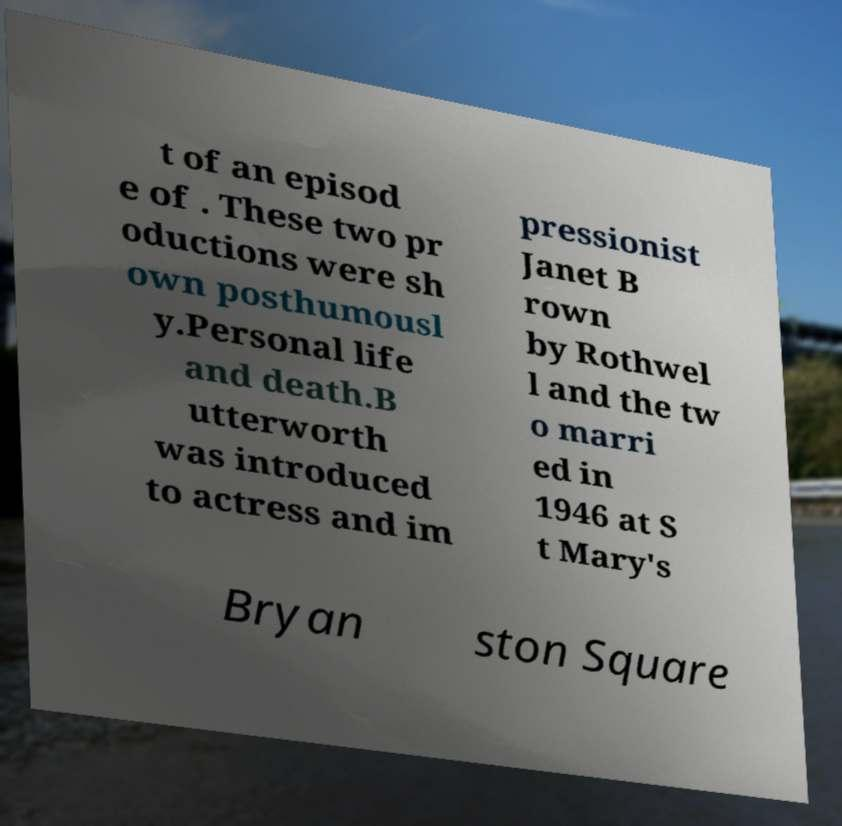Can you read and provide the text displayed in the image?This photo seems to have some interesting text. Can you extract and type it out for me? t of an episod e of . These two pr oductions were sh own posthumousl y.Personal life and death.B utterworth was introduced to actress and im pressionist Janet B rown by Rothwel l and the tw o marri ed in 1946 at S t Mary's Bryan ston Square 